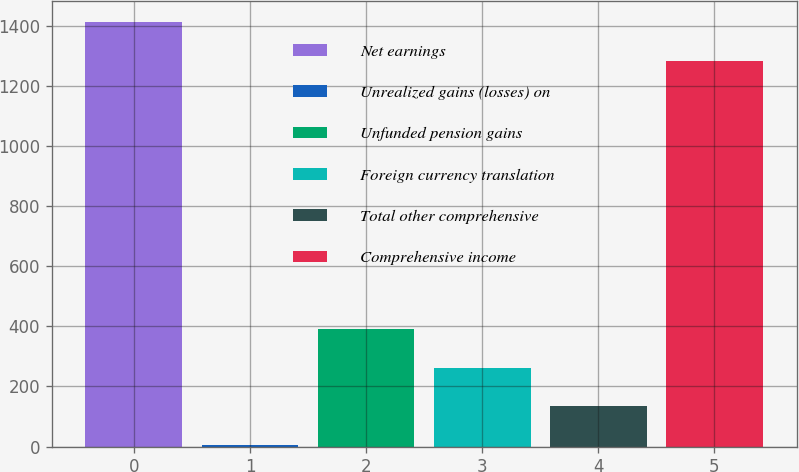Convert chart to OTSL. <chart><loc_0><loc_0><loc_500><loc_500><bar_chart><fcel>Net earnings<fcel>Unrealized gains (losses) on<fcel>Unfunded pension gains<fcel>Foreign currency translation<fcel>Total other comprehensive<fcel>Comprehensive income<nl><fcel>1412.4<fcel>4<fcel>392.2<fcel>262.8<fcel>133.4<fcel>1283<nl></chart> 